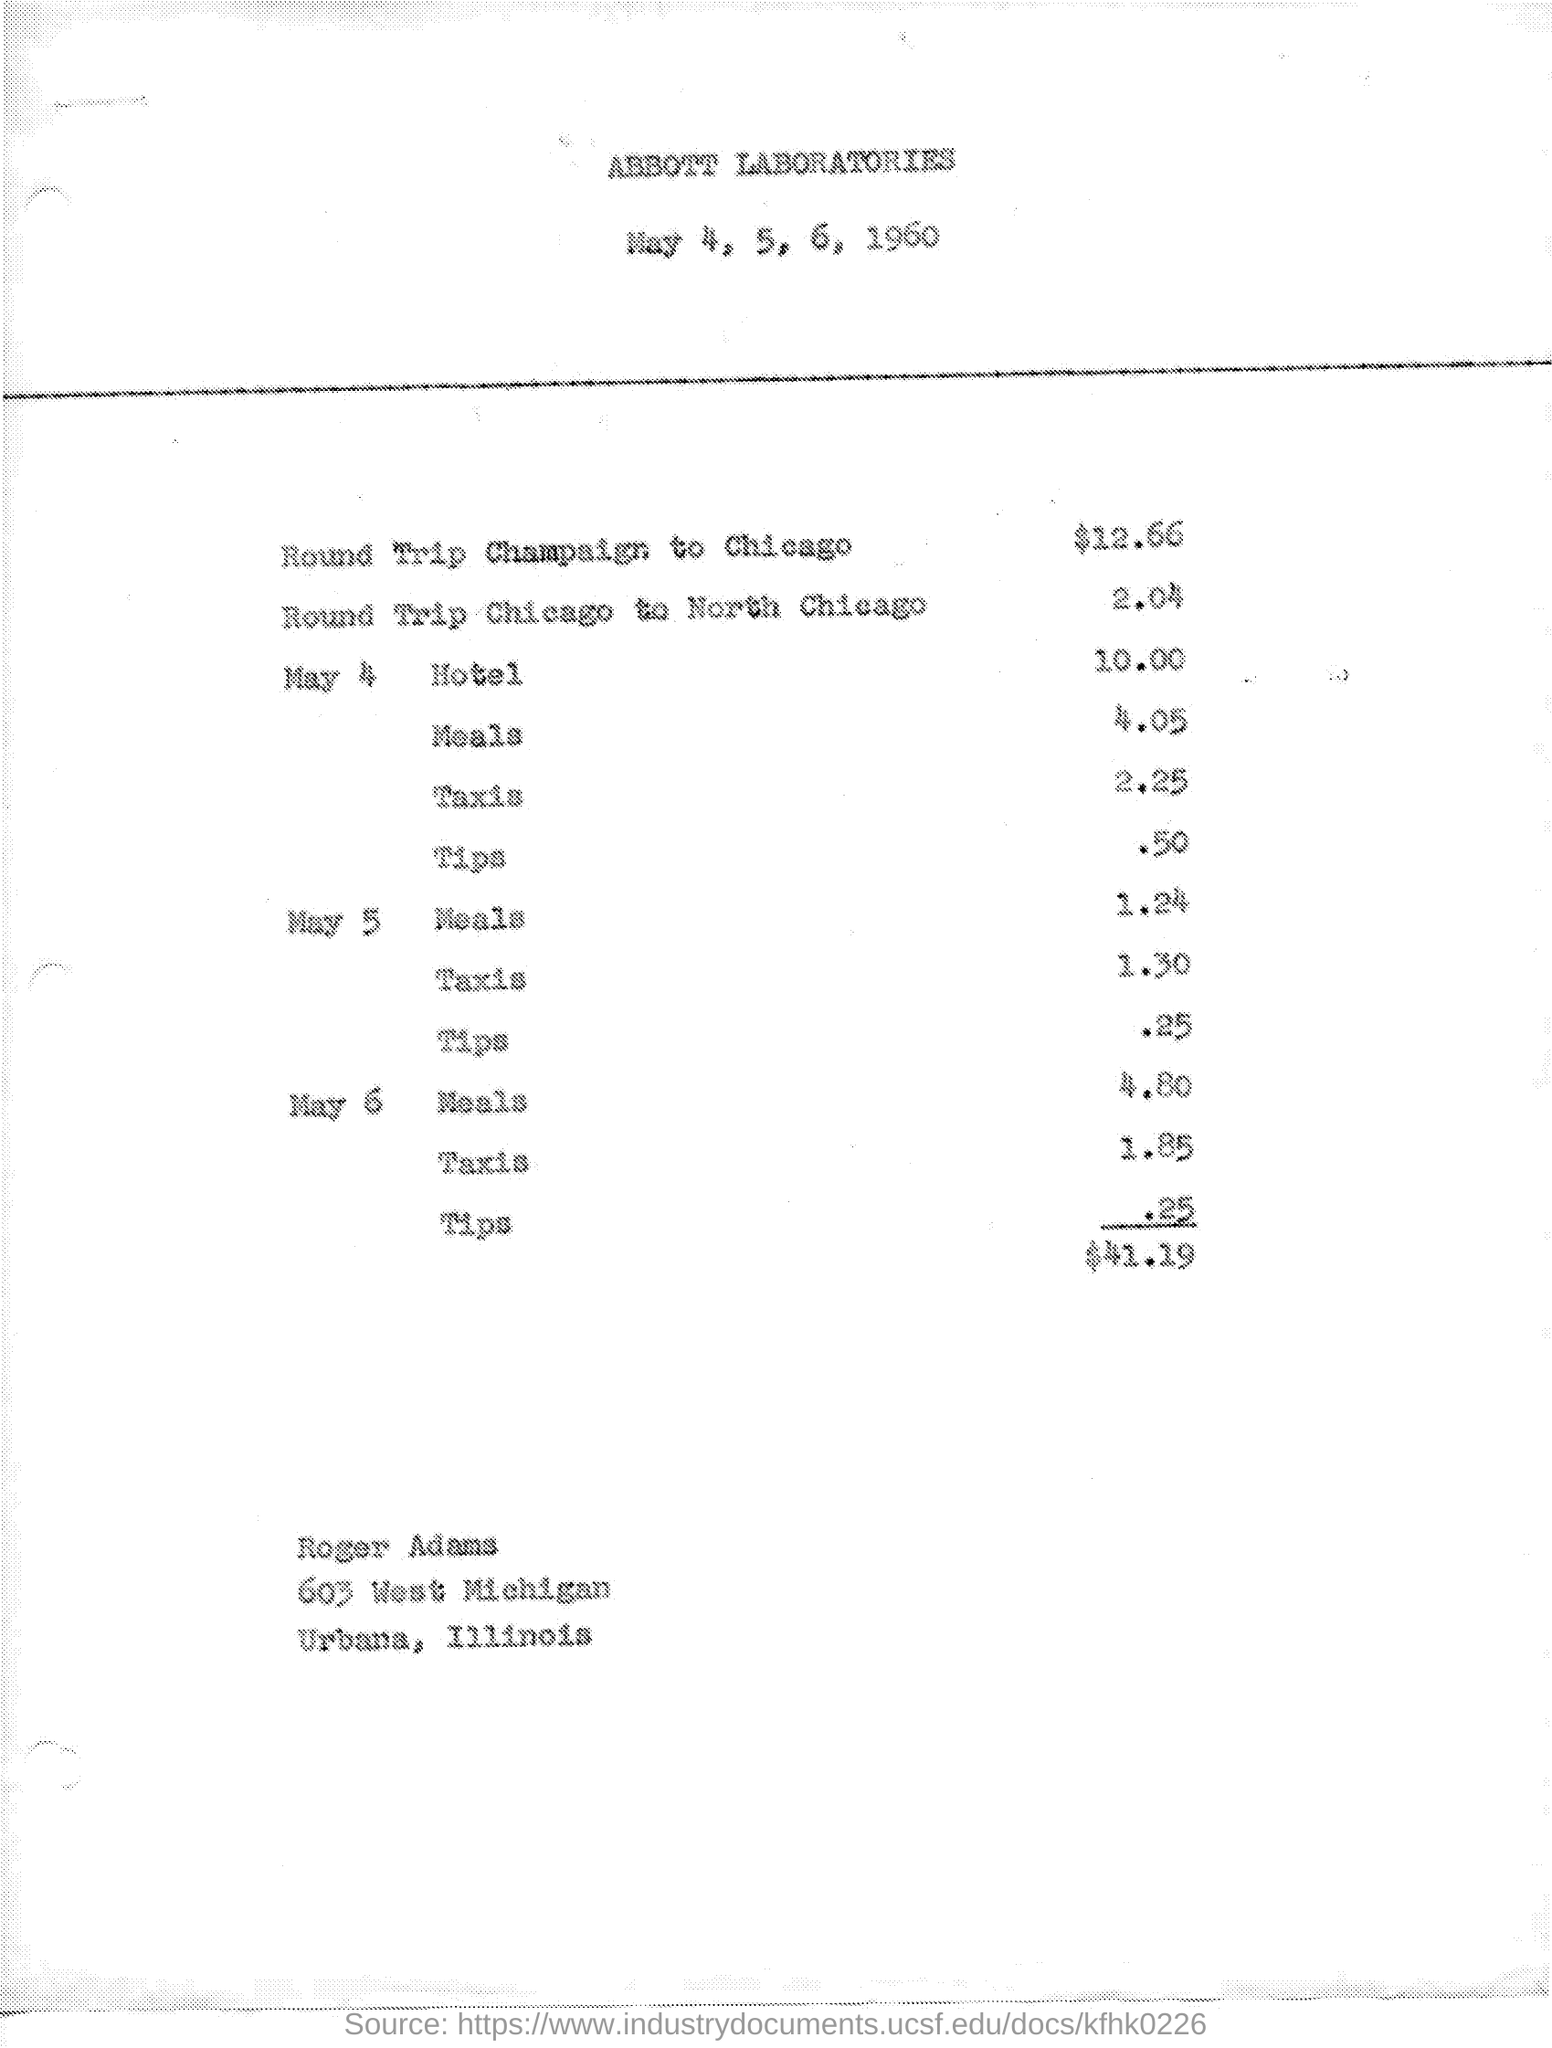Which laboratory is mentioned?
Provide a succinct answer. ABBOTT LABORATORIES. What are the dates mentioned?
Provide a short and direct response. May 4, 5, 6, 1960. What is the total amount?
Offer a terse response. $41.19. 